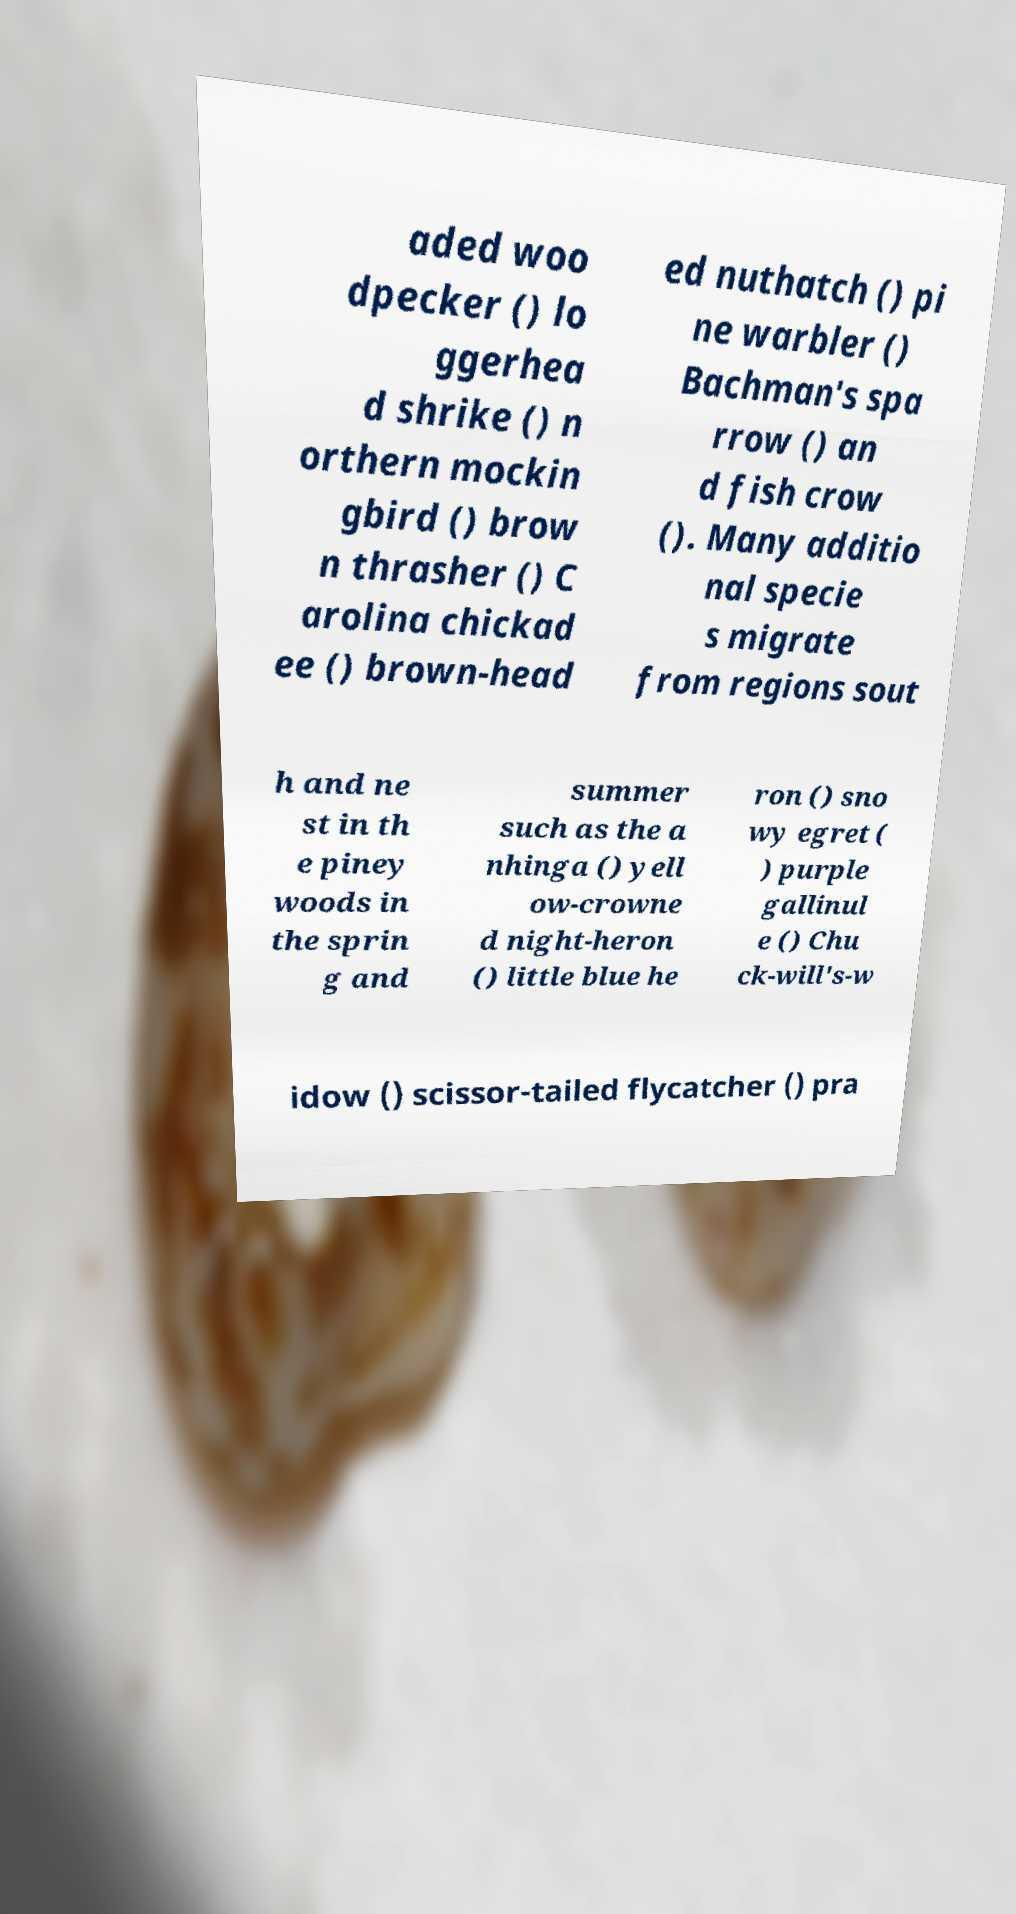Could you assist in decoding the text presented in this image and type it out clearly? aded woo dpecker () lo ggerhea d shrike () n orthern mockin gbird () brow n thrasher () C arolina chickad ee () brown-head ed nuthatch () pi ne warbler () Bachman's spa rrow () an d fish crow (). Many additio nal specie s migrate from regions sout h and ne st in th e piney woods in the sprin g and summer such as the a nhinga () yell ow-crowne d night-heron () little blue he ron () sno wy egret ( ) purple gallinul e () Chu ck-will's-w idow () scissor-tailed flycatcher () pra 